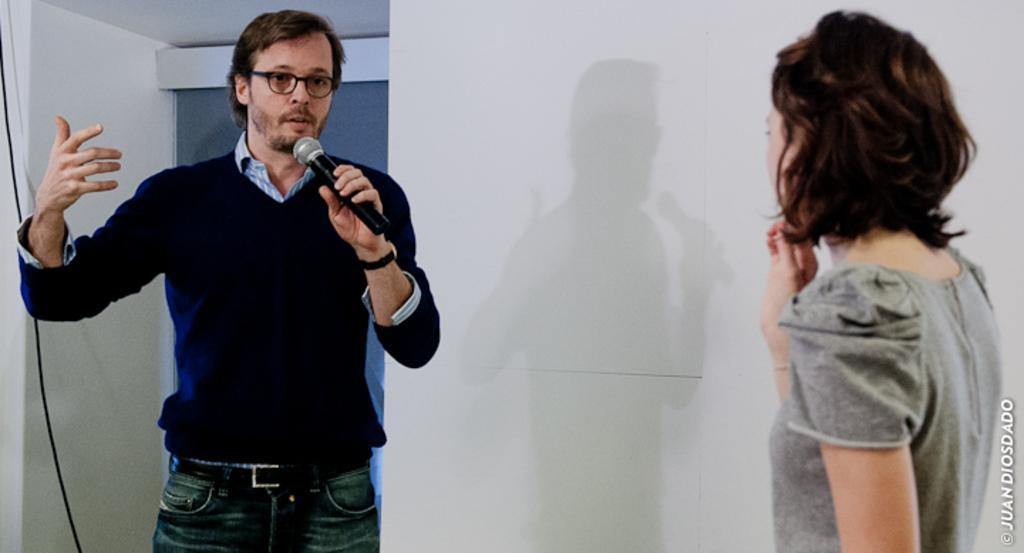Describe this image in one or two sentences. The person wearing blue dress is standing and speaking in front of a mic and there is also other woman standing in the right corner and the background is white in color. 